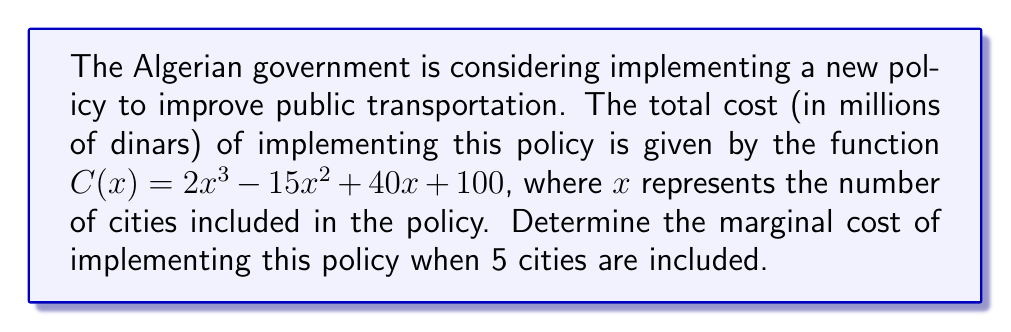Teach me how to tackle this problem. To determine the marginal cost, we need to find the derivative of the cost function and evaluate it at $x = 5$. Here's the step-by-step process:

1) The cost function is $C(x) = 2x^3 - 15x^2 + 40x + 100$

2) To find the marginal cost function, we need to differentiate $C(x)$ with respect to $x$:
   $$\frac{d}{dx}C(x) = \frac{d}{dx}(2x^3 - 15x^2 + 40x + 100)$$

3) Using the power rule and constant rule of differentiation:
   $$\frac{d}{dx}C(x) = 6x^2 - 30x + 40$$

4) This derivative function represents the marginal cost function, which we can call $MC(x)$:
   $$MC(x) = 6x^2 - 30x + 40$$

5) To find the marginal cost when 5 cities are included, we substitute $x = 5$ into $MC(x)$:
   $$MC(5) = 6(5)^2 - 30(5) + 40$$

6) Simplify:
   $$MC(5) = 6(25) - 150 + 40 = 150 - 150 + 40 = 40$$

Therefore, the marginal cost of implementing the policy when 5 cities are included is 40 million dinars.
Answer: $40$ million dinars 